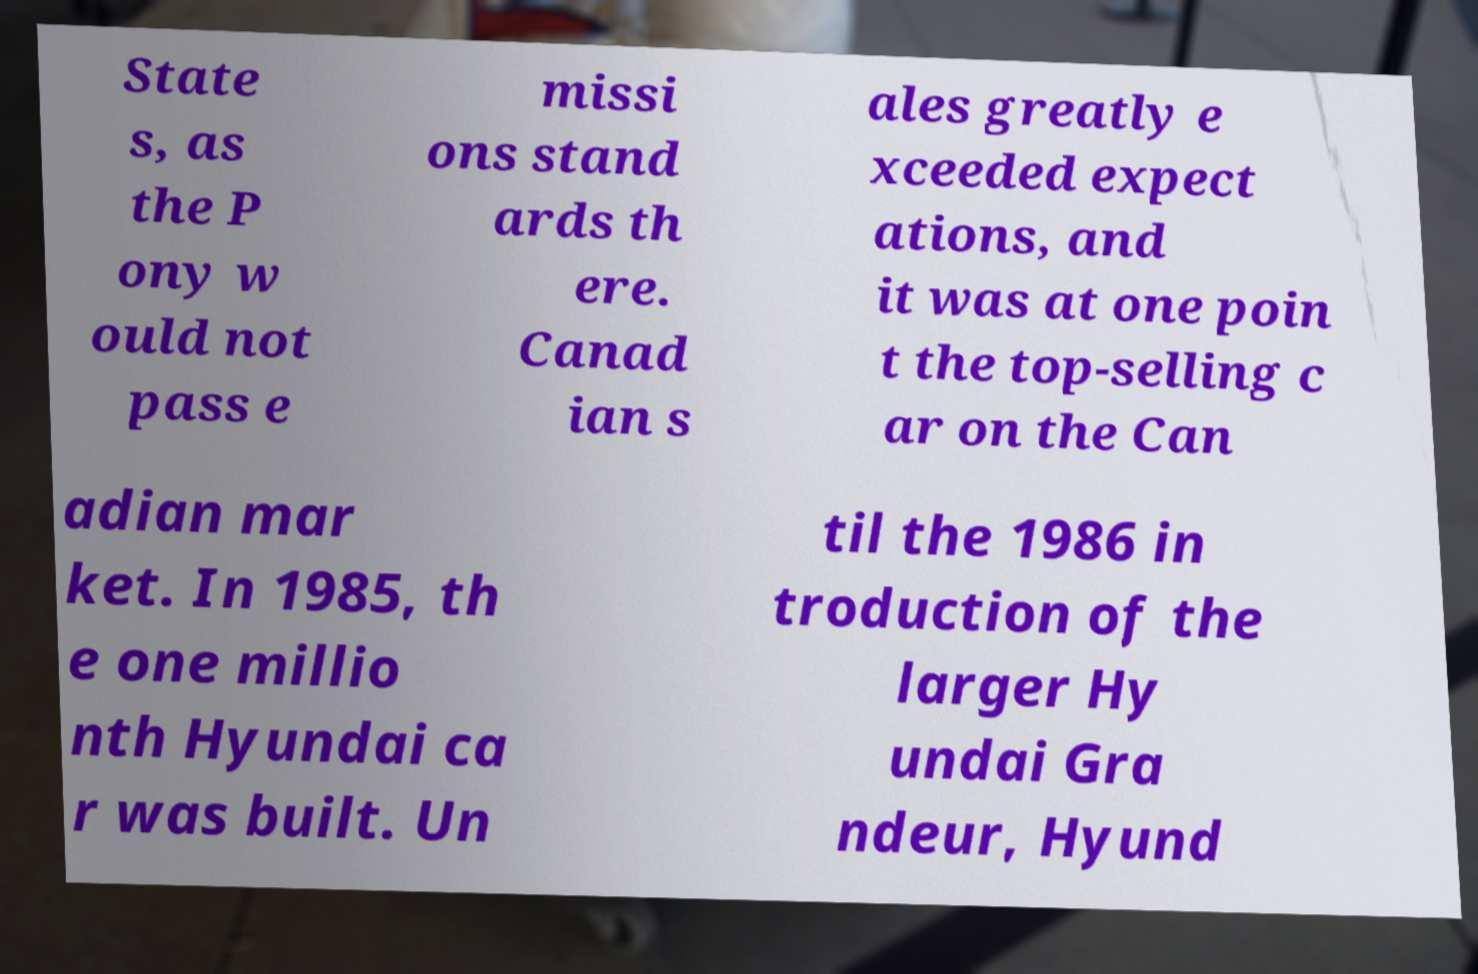Could you extract and type out the text from this image? State s, as the P ony w ould not pass e missi ons stand ards th ere. Canad ian s ales greatly e xceeded expect ations, and it was at one poin t the top-selling c ar on the Can adian mar ket. In 1985, th e one millio nth Hyundai ca r was built. Un til the 1986 in troduction of the larger Hy undai Gra ndeur, Hyund 